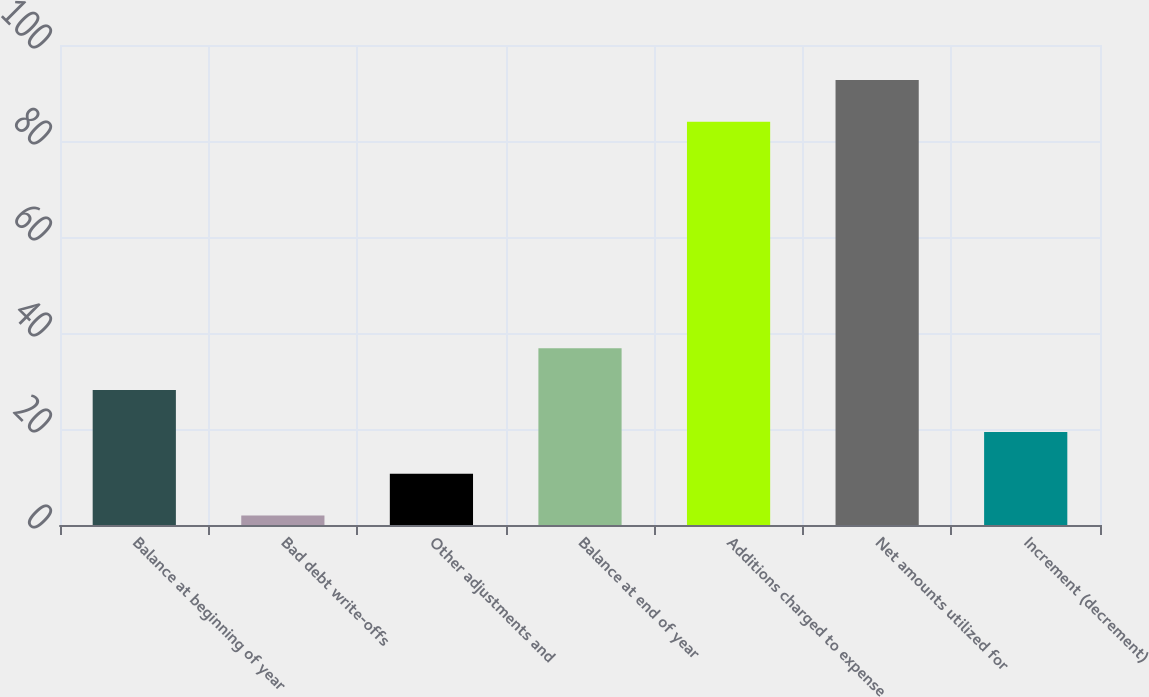Convert chart. <chart><loc_0><loc_0><loc_500><loc_500><bar_chart><fcel>Balance at beginning of year<fcel>Bad debt write-offs<fcel>Other adjustments and<fcel>Balance at end of year<fcel>Additions charged to expense<fcel>Net amounts utilized for<fcel>Increment (decrement)<nl><fcel>28.1<fcel>2<fcel>10.7<fcel>36.8<fcel>84<fcel>92.7<fcel>19.4<nl></chart> 